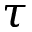<formula> <loc_0><loc_0><loc_500><loc_500>\tau</formula> 